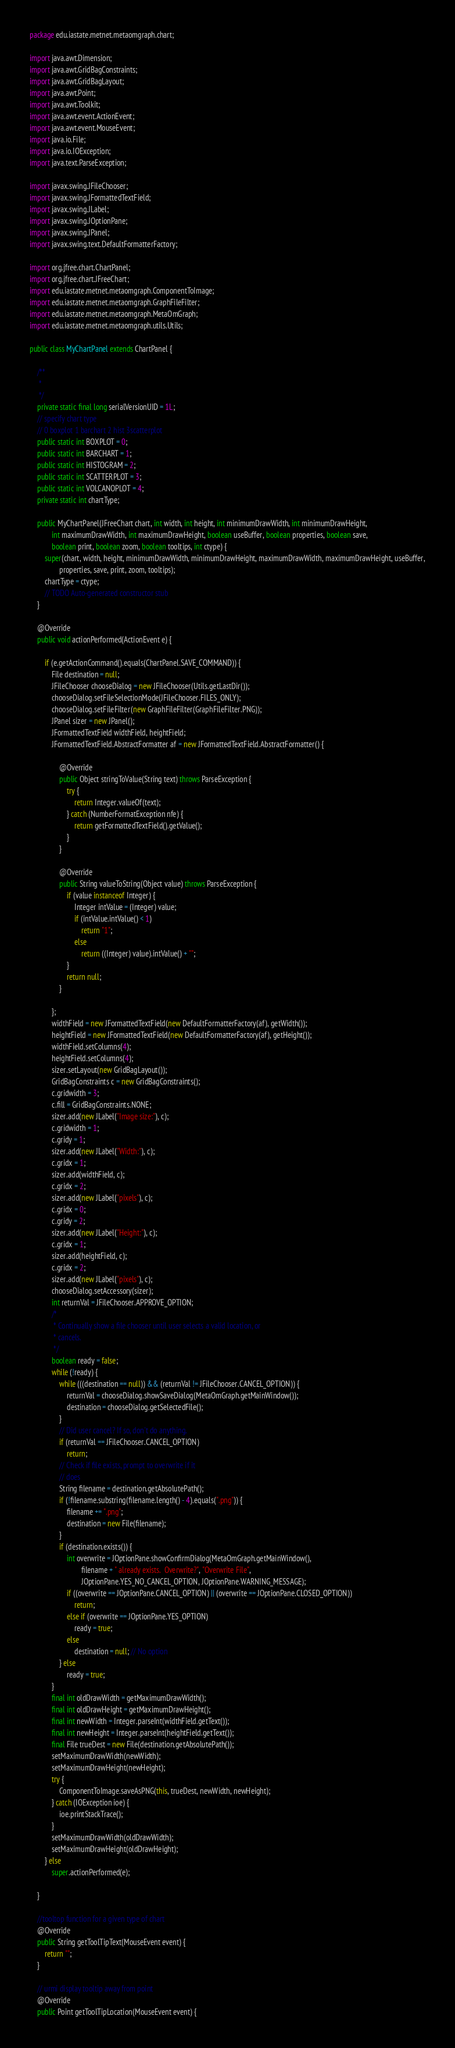<code> <loc_0><loc_0><loc_500><loc_500><_Java_>package edu.iastate.metnet.metaomgraph.chart;

import java.awt.Dimension;
import java.awt.GridBagConstraints;
import java.awt.GridBagLayout;
import java.awt.Point;
import java.awt.Toolkit;
import java.awt.event.ActionEvent;
import java.awt.event.MouseEvent;
import java.io.File;
import java.io.IOException;
import java.text.ParseException;

import javax.swing.JFileChooser;
import javax.swing.JFormattedTextField;
import javax.swing.JLabel;
import javax.swing.JOptionPane;
import javax.swing.JPanel;
import javax.swing.text.DefaultFormatterFactory;

import org.jfree.chart.ChartPanel;
import org.jfree.chart.JFreeChart;
import edu.iastate.metnet.metaomgraph.ComponentToImage;
import edu.iastate.metnet.metaomgraph.GraphFileFilter;
import edu.iastate.metnet.metaomgraph.MetaOmGraph;
import edu.iastate.metnet.metaomgraph.utils.Utils;

public class MyChartPanel extends ChartPanel {

	/**
	 * 
	 */
	private static final long serialVersionUID = 1L;
	// specify chart type
	// 0 boxplot 1 barchart 2 hist 3scatterplot
	public static int BOXPLOT = 0;
	public static int BARCHART = 1;
	public static int HISTOGRAM = 2;
	public static int SCATTERPLOT = 3;
	public static int VOLCANOPLOT = 4;
	private static int chartType;

	public MyChartPanel(JFreeChart chart, int width, int height, int minimumDrawWidth, int minimumDrawHeight,
			int maximumDrawWidth, int maximumDrawHeight, boolean useBuffer, boolean properties, boolean save,
			boolean print, boolean zoom, boolean tooltips, int ctype) {
		super(chart, width, height, minimumDrawWidth, minimumDrawHeight, maximumDrawWidth, maximumDrawHeight, useBuffer,
				properties, save, print, zoom, tooltips);
		chartType = ctype;
		// TODO Auto-generated constructor stub
	}

	@Override
	public void actionPerformed(ActionEvent e) {

		if (e.getActionCommand().equals(ChartPanel.SAVE_COMMAND)) {
			File destination = null;
			JFileChooser chooseDialog = new JFileChooser(Utils.getLastDir());
			chooseDialog.setFileSelectionMode(JFileChooser.FILES_ONLY);
			chooseDialog.setFileFilter(new GraphFileFilter(GraphFileFilter.PNG));
			JPanel sizer = new JPanel();
			JFormattedTextField widthField, heightField;
			JFormattedTextField.AbstractFormatter af = new JFormattedTextField.AbstractFormatter() {

				@Override
				public Object stringToValue(String text) throws ParseException {
					try {
						return Integer.valueOf(text);
					} catch (NumberFormatException nfe) {
						return getFormattedTextField().getValue();
					}
				}

				@Override
				public String valueToString(Object value) throws ParseException {
					if (value instanceof Integer) {
						Integer intValue = (Integer) value;
						if (intValue.intValue() < 1)
							return "1";
						else
							return ((Integer) value).intValue() + "";
					}
					return null;
				}

			};
			widthField = new JFormattedTextField(new DefaultFormatterFactory(af), getWidth());
			heightField = new JFormattedTextField(new DefaultFormatterFactory(af), getHeight());
			widthField.setColumns(4);
			heightField.setColumns(4);
			sizer.setLayout(new GridBagLayout());
			GridBagConstraints c = new GridBagConstraints();
			c.gridwidth = 3;
			c.fill = GridBagConstraints.NONE;
			sizer.add(new JLabel("Image size:"), c);
			c.gridwidth = 1;
			c.gridy = 1;
			sizer.add(new JLabel("Width:"), c);
			c.gridx = 1;
			sizer.add(widthField, c);
			c.gridx = 2;
			sizer.add(new JLabel("pixels"), c);
			c.gridx = 0;
			c.gridy = 2;
			sizer.add(new JLabel("Height:"), c);
			c.gridx = 1;
			sizer.add(heightField, c);
			c.gridx = 2;
			sizer.add(new JLabel("pixels"), c);
			chooseDialog.setAccessory(sizer);
			int returnVal = JFileChooser.APPROVE_OPTION;
			/*
			 * Continually show a file chooser until user selects a valid location, or
			 * cancels.
			 */
			boolean ready = false;
			while (!ready) {
				while (((destination == null)) && (returnVal != JFileChooser.CANCEL_OPTION)) {
					returnVal = chooseDialog.showSaveDialog(MetaOmGraph.getMainWindow());
					destination = chooseDialog.getSelectedFile();
				}
				// Did user cancel? If so, don't do anything.
				if (returnVal == JFileChooser.CANCEL_OPTION)
					return;
				// Check if file exists, prompt to overwrite if it
				// does
				String filename = destination.getAbsolutePath();
				if (!filename.substring(filename.length() - 4).equals(".png")) {
					filename += ".png";
					destination = new File(filename);
				}
				if (destination.exists()) {
					int overwrite = JOptionPane.showConfirmDialog(MetaOmGraph.getMainWindow(),
							filename + " already exists.  Overwrite?", "Overwrite File",
							JOptionPane.YES_NO_CANCEL_OPTION, JOptionPane.WARNING_MESSAGE);
					if ((overwrite == JOptionPane.CANCEL_OPTION) || (overwrite == JOptionPane.CLOSED_OPTION))
						return;
					else if (overwrite == JOptionPane.YES_OPTION)
						ready = true;
					else
						destination = null; // No option
				} else
					ready = true;
			}
			final int oldDrawWidth = getMaximumDrawWidth();
			final int oldDrawHeight = getMaximumDrawHeight();
			final int newWidth = Integer.parseInt(widthField.getText());
			final int newHeight = Integer.parseInt(heightField.getText());
			final File trueDest = new File(destination.getAbsolutePath());
			setMaximumDrawWidth(newWidth);
			setMaximumDrawHeight(newHeight);
			try {
				ComponentToImage.saveAsPNG(this, trueDest, newWidth, newHeight);
			} catch (IOException ioe) {
				ioe.printStackTrace();
			}
			setMaximumDrawWidth(oldDrawWidth);
			setMaximumDrawHeight(oldDrawHeight);
		} else
			super.actionPerformed(e);

	}

	//tooltop function for a given type of chart
	@Override
	public String getToolTipText(MouseEvent event) {
		return "";
	}

	// urmi display tooltip away from point
	@Override
	public Point getToolTipLocation(MouseEvent event) {</code> 